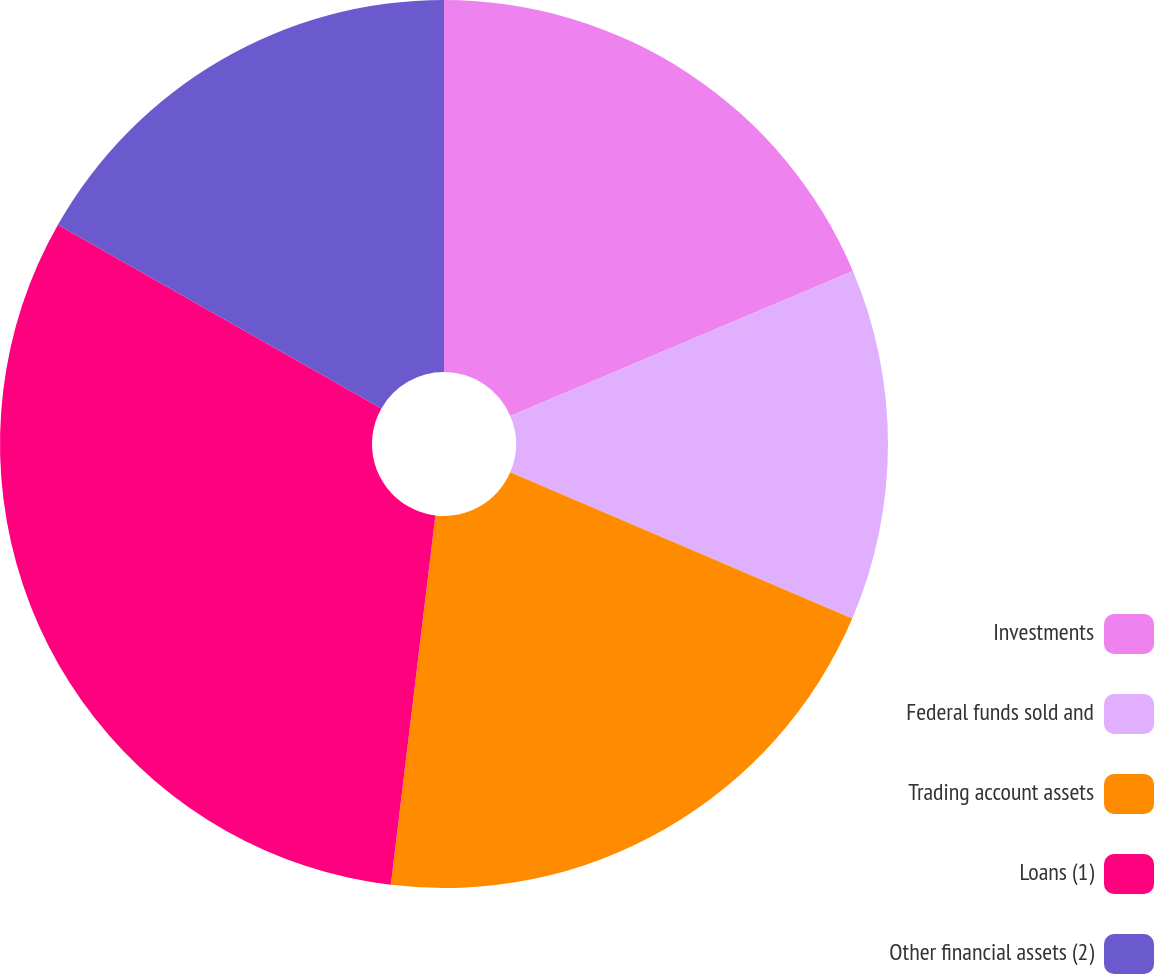<chart> <loc_0><loc_0><loc_500><loc_500><pie_chart><fcel>Investments<fcel>Federal funds sold and<fcel>Trading account assets<fcel>Loans (1)<fcel>Other financial assets (2)<nl><fcel>18.63%<fcel>12.8%<fcel>20.48%<fcel>31.31%<fcel>16.78%<nl></chart> 